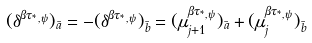<formula> <loc_0><loc_0><loc_500><loc_500>( \delta ^ { \beta \tau _ { ^ { * } , \psi } } ) _ { \bar { a } } = - ( \delta ^ { \beta \tau _ { ^ { * } , \psi } } ) _ { \bar { b } } = ( \mu _ { j + 1 } ^ { \beta \tau _ { ^ { * } , \psi } } ) _ { \bar { a } } + ( \mu _ { j } ^ { \beta \tau _ { ^ { * } , \psi } } ) _ { \bar { b } }</formula> 